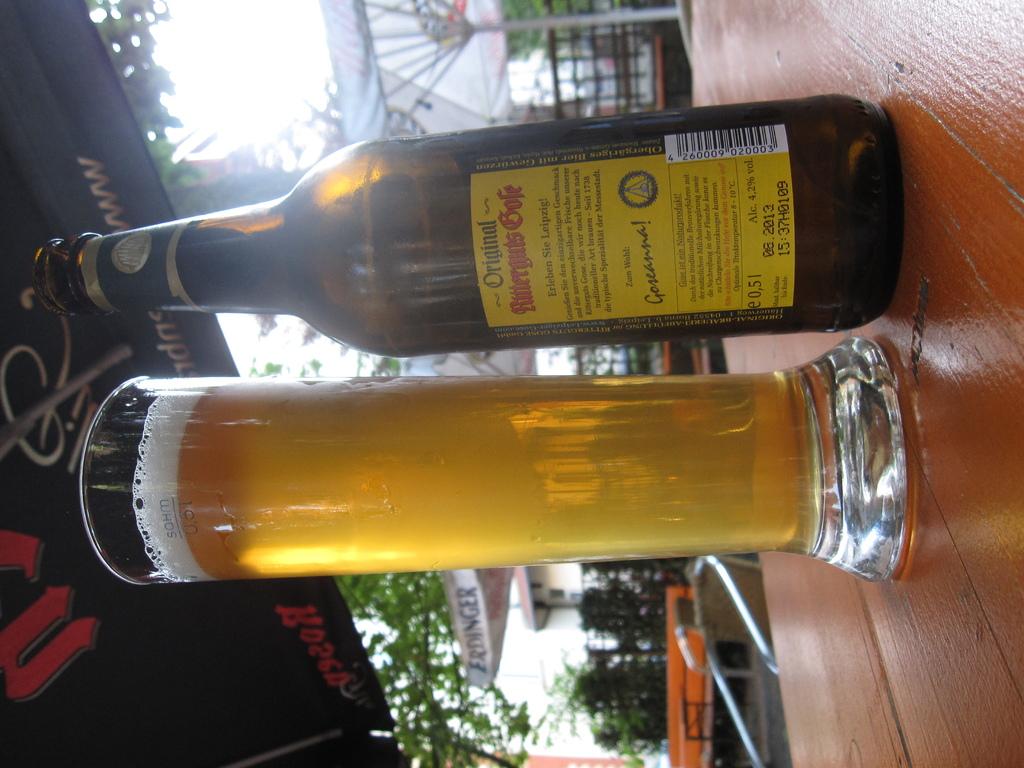Is that an original bottle?
Ensure brevity in your answer.  Yes. What word appears the red lettering?
Your response must be concise. Unanswerable. 